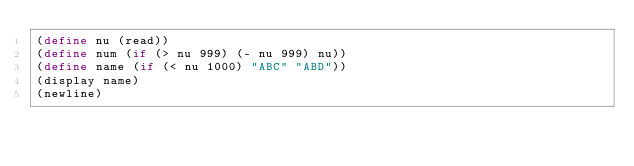Convert code to text. <code><loc_0><loc_0><loc_500><loc_500><_Scheme_>(define nu (read))
(define num (if (> nu 999) (- nu 999) nu))
(define name (if (< nu 1000) "ABC" "ABD"))
(display name)
(newline)</code> 